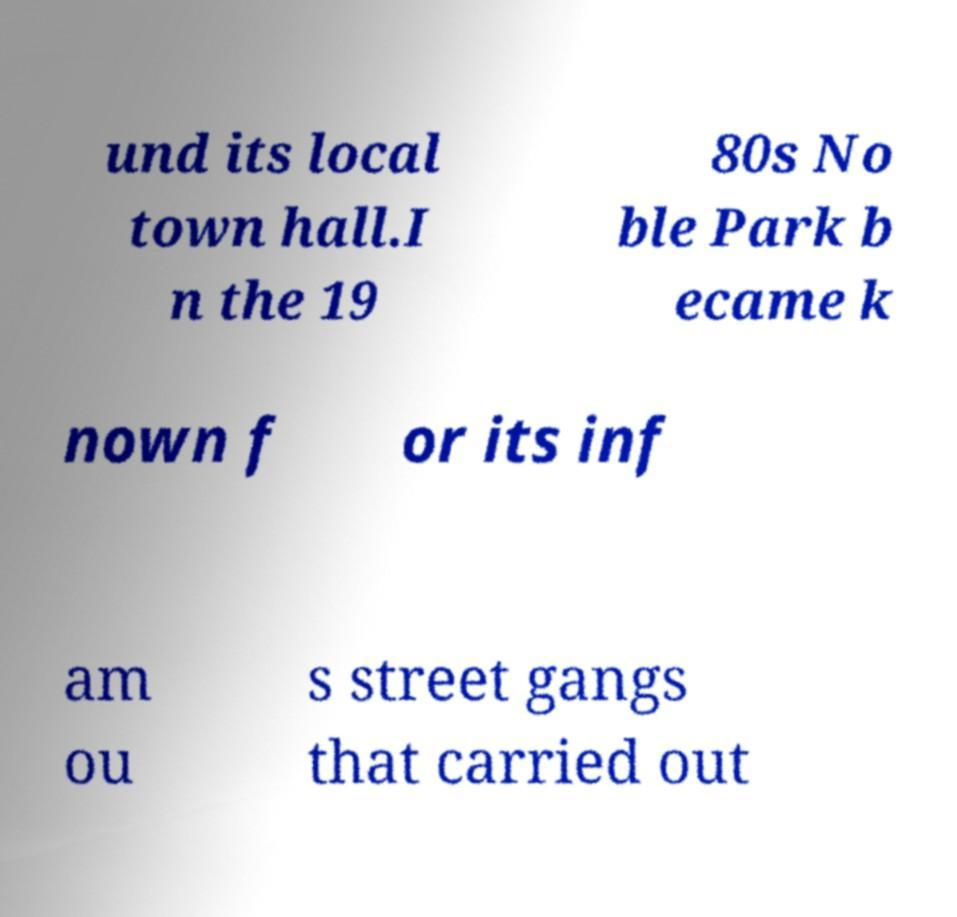There's text embedded in this image that I need extracted. Can you transcribe it verbatim? und its local town hall.I n the 19 80s No ble Park b ecame k nown f or its inf am ou s street gangs that carried out 